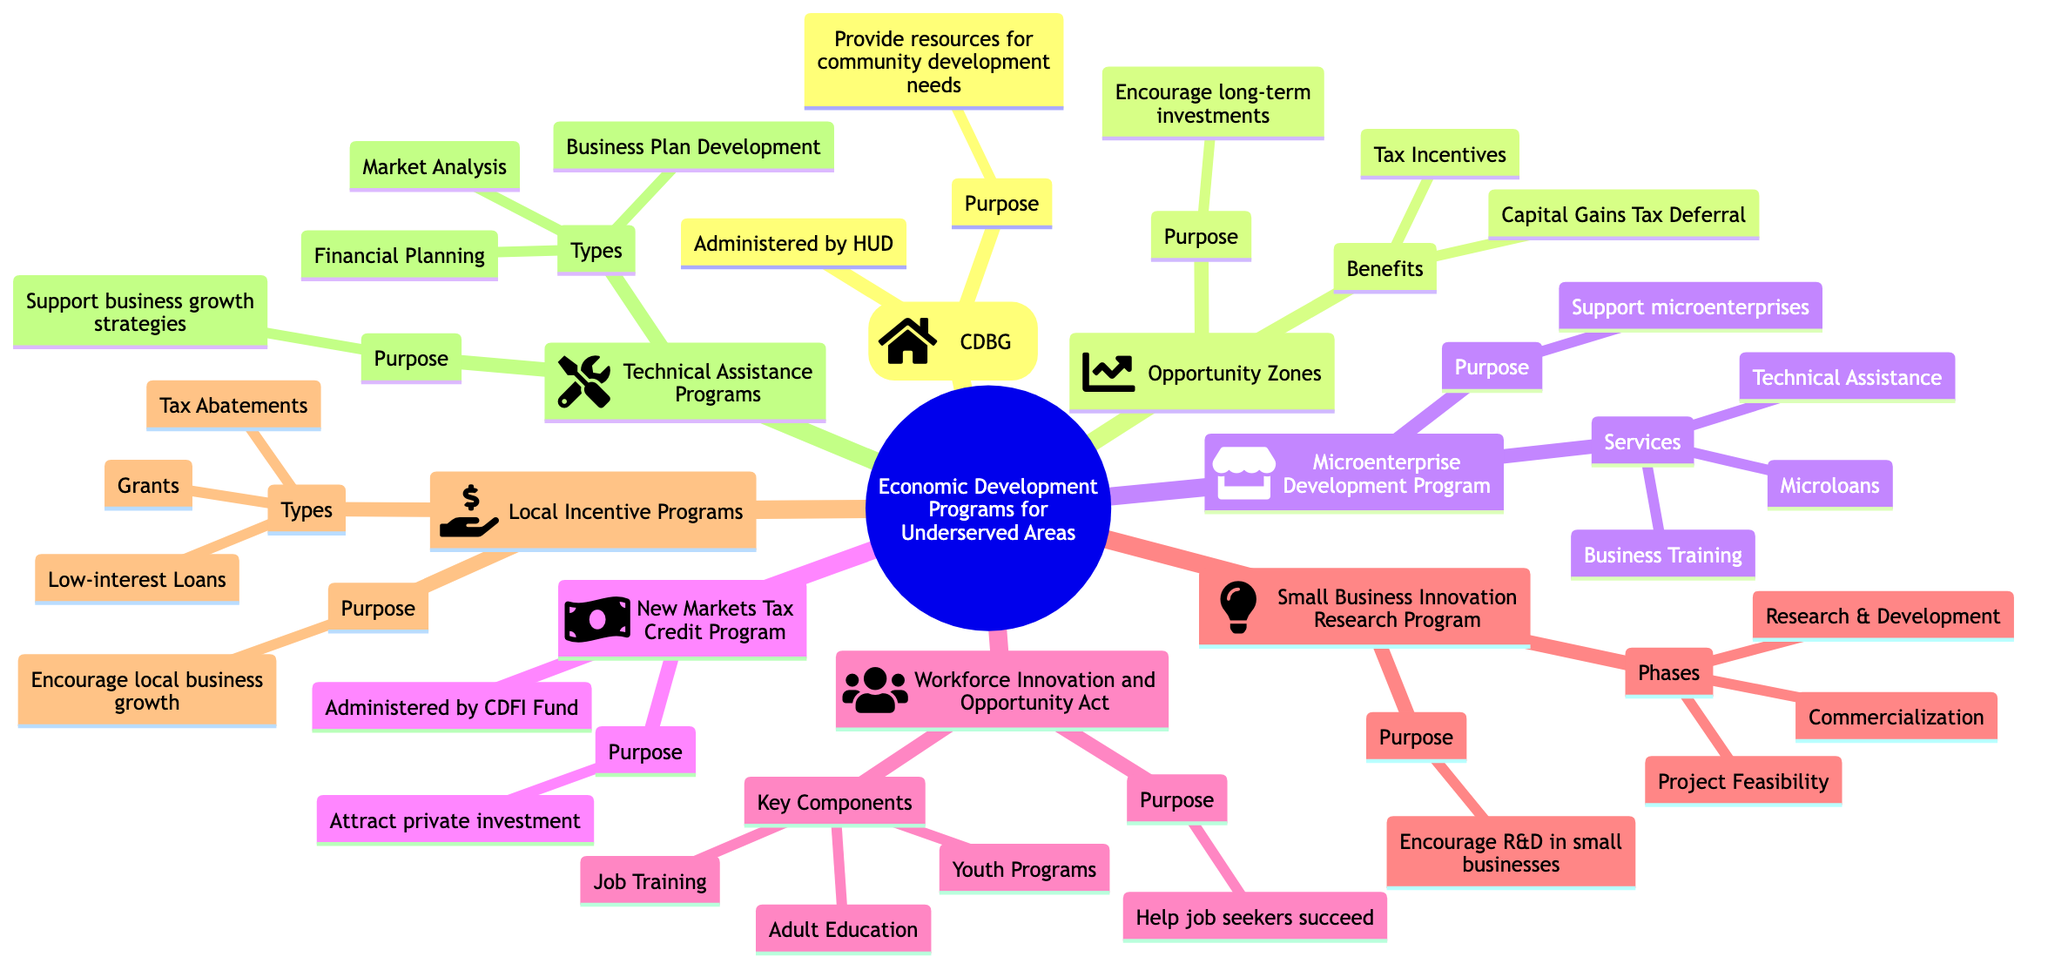What is the purpose of the Community Development Block Grant? The diagram states that the purpose of the Community Development Block Grant is to provide communities with resources to address a wide range of unique community development needs.
Answer: Provide communities with resources to address a wide range of unique community development needs Who administers the New Markets Tax Credit Program? According to the diagram, the New Markets Tax Credit Program is administered by the Community Development Financial Institutions Fund.
Answer: Community Development Financial Institutions Fund What are the benefits of Opportunity Zones? The diagram lists the benefits of Opportunity Zones as Tax Incentives and Capital Gains Tax Deferral.
Answer: Tax Incentives, Capital Gains Tax Deferral How many phases are there in the Small Business Innovation Research Program? The diagram shows that the Small Business Innovation Research Program has three phases: Project Feasibility, Research/Research and Development, and Commercialization.
Answer: Three What is a key component of the Workforce Innovation and Opportunity Act? The diagram mentions that Job Training is one of the key components of the Workforce Innovation and Opportunity Act.
Answer: Job Training What types of local incentive programs are mentioned? The diagram states that the types of local incentive programs include Tax Abatements, Grants, and Low-interest Loans.
Answer: Tax Abatements, Grants, Low-interest Loans What purpose do Technical Assistance Programs serve? According to the diagram, the purpose of Technical Assistance Programs is to support businesses and entrepreneurs with growth strategies.
Answer: Support businesses and entrepreneurs with growth strategies Which program is designed to support the development of microenterprises? The diagram indicates that the Microenterprise Development Program is designed to support the development and growth of microenterprises in underserved areas.
Answer: Microenterprise Development Program 